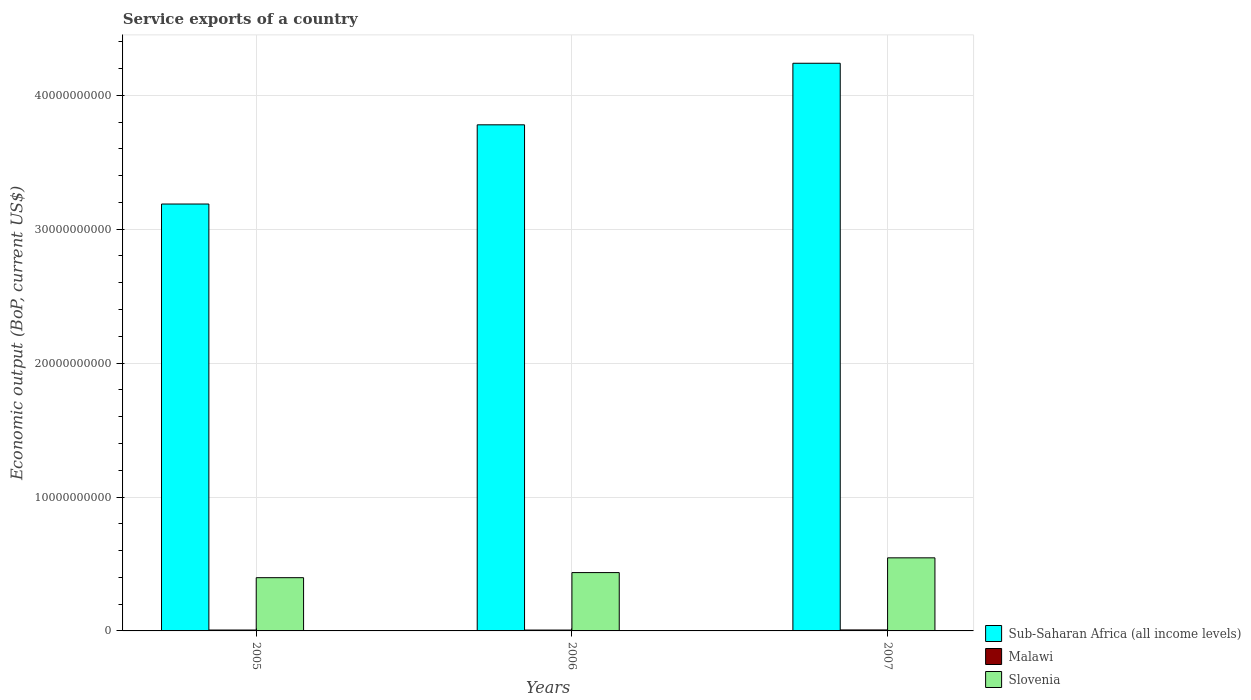Are the number of bars on each tick of the X-axis equal?
Your answer should be very brief. Yes. How many bars are there on the 2nd tick from the left?
Give a very brief answer. 3. In how many cases, is the number of bars for a given year not equal to the number of legend labels?
Offer a very short reply. 0. What is the service exports in Sub-Saharan Africa (all income levels) in 2005?
Make the answer very short. 3.19e+1. Across all years, what is the maximum service exports in Slovenia?
Provide a succinct answer. 5.46e+09. Across all years, what is the minimum service exports in Slovenia?
Your response must be concise. 3.98e+09. In which year was the service exports in Slovenia maximum?
Provide a succinct answer. 2007. In which year was the service exports in Malawi minimum?
Offer a terse response. 2006. What is the total service exports in Slovenia in the graph?
Your response must be concise. 1.38e+1. What is the difference between the service exports in Malawi in 2005 and that in 2007?
Give a very brief answer. -6.69e+06. What is the difference between the service exports in Slovenia in 2007 and the service exports in Malawi in 2006?
Offer a very short reply. 5.39e+09. What is the average service exports in Sub-Saharan Africa (all income levels) per year?
Provide a short and direct response. 3.74e+1. In the year 2007, what is the difference between the service exports in Malawi and service exports in Slovenia?
Your answer should be compact. -5.38e+09. What is the ratio of the service exports in Sub-Saharan Africa (all income levels) in 2005 to that in 2007?
Provide a short and direct response. 0.75. Is the difference between the service exports in Malawi in 2005 and 2007 greater than the difference between the service exports in Slovenia in 2005 and 2007?
Make the answer very short. Yes. What is the difference between the highest and the second highest service exports in Slovenia?
Provide a short and direct response. 1.10e+09. What is the difference between the highest and the lowest service exports in Sub-Saharan Africa (all income levels)?
Provide a short and direct response. 1.05e+1. In how many years, is the service exports in Slovenia greater than the average service exports in Slovenia taken over all years?
Keep it short and to the point. 1. What does the 3rd bar from the left in 2006 represents?
Provide a short and direct response. Slovenia. What does the 2nd bar from the right in 2005 represents?
Offer a very short reply. Malawi. How many bars are there?
Your response must be concise. 9. How many years are there in the graph?
Offer a very short reply. 3. What is the difference between two consecutive major ticks on the Y-axis?
Keep it short and to the point. 1.00e+1. Where does the legend appear in the graph?
Ensure brevity in your answer.  Bottom right. What is the title of the graph?
Your answer should be very brief. Service exports of a country. Does "Aruba" appear as one of the legend labels in the graph?
Your response must be concise. No. What is the label or title of the Y-axis?
Offer a very short reply. Economic output (BoP, current US$). What is the Economic output (BoP, current US$) of Sub-Saharan Africa (all income levels) in 2005?
Your response must be concise. 3.19e+1. What is the Economic output (BoP, current US$) in Malawi in 2005?
Offer a terse response. 6.73e+07. What is the Economic output (BoP, current US$) of Slovenia in 2005?
Give a very brief answer. 3.98e+09. What is the Economic output (BoP, current US$) of Sub-Saharan Africa (all income levels) in 2006?
Make the answer very short. 3.78e+1. What is the Economic output (BoP, current US$) in Malawi in 2006?
Ensure brevity in your answer.  6.45e+07. What is the Economic output (BoP, current US$) in Slovenia in 2006?
Give a very brief answer. 4.36e+09. What is the Economic output (BoP, current US$) of Sub-Saharan Africa (all income levels) in 2007?
Your answer should be very brief. 4.24e+1. What is the Economic output (BoP, current US$) of Malawi in 2007?
Provide a short and direct response. 7.40e+07. What is the Economic output (BoP, current US$) of Slovenia in 2007?
Your answer should be very brief. 5.46e+09. Across all years, what is the maximum Economic output (BoP, current US$) in Sub-Saharan Africa (all income levels)?
Offer a very short reply. 4.24e+1. Across all years, what is the maximum Economic output (BoP, current US$) of Malawi?
Your answer should be very brief. 7.40e+07. Across all years, what is the maximum Economic output (BoP, current US$) in Slovenia?
Make the answer very short. 5.46e+09. Across all years, what is the minimum Economic output (BoP, current US$) of Sub-Saharan Africa (all income levels)?
Your response must be concise. 3.19e+1. Across all years, what is the minimum Economic output (BoP, current US$) in Malawi?
Offer a terse response. 6.45e+07. Across all years, what is the minimum Economic output (BoP, current US$) of Slovenia?
Your answer should be compact. 3.98e+09. What is the total Economic output (BoP, current US$) of Sub-Saharan Africa (all income levels) in the graph?
Your answer should be compact. 1.12e+11. What is the total Economic output (BoP, current US$) of Malawi in the graph?
Keep it short and to the point. 2.06e+08. What is the total Economic output (BoP, current US$) of Slovenia in the graph?
Give a very brief answer. 1.38e+1. What is the difference between the Economic output (BoP, current US$) in Sub-Saharan Africa (all income levels) in 2005 and that in 2006?
Offer a terse response. -5.91e+09. What is the difference between the Economic output (BoP, current US$) of Malawi in 2005 and that in 2006?
Provide a short and direct response. 2.81e+06. What is the difference between the Economic output (BoP, current US$) in Slovenia in 2005 and that in 2006?
Your answer should be compact. -3.81e+08. What is the difference between the Economic output (BoP, current US$) of Sub-Saharan Africa (all income levels) in 2005 and that in 2007?
Provide a short and direct response. -1.05e+1. What is the difference between the Economic output (BoP, current US$) of Malawi in 2005 and that in 2007?
Provide a short and direct response. -6.69e+06. What is the difference between the Economic output (BoP, current US$) in Slovenia in 2005 and that in 2007?
Offer a very short reply. -1.48e+09. What is the difference between the Economic output (BoP, current US$) of Sub-Saharan Africa (all income levels) in 2006 and that in 2007?
Offer a very short reply. -4.60e+09. What is the difference between the Economic output (BoP, current US$) of Malawi in 2006 and that in 2007?
Make the answer very short. -9.50e+06. What is the difference between the Economic output (BoP, current US$) of Slovenia in 2006 and that in 2007?
Your response must be concise. -1.10e+09. What is the difference between the Economic output (BoP, current US$) of Sub-Saharan Africa (all income levels) in 2005 and the Economic output (BoP, current US$) of Malawi in 2006?
Your response must be concise. 3.18e+1. What is the difference between the Economic output (BoP, current US$) of Sub-Saharan Africa (all income levels) in 2005 and the Economic output (BoP, current US$) of Slovenia in 2006?
Offer a terse response. 2.75e+1. What is the difference between the Economic output (BoP, current US$) in Malawi in 2005 and the Economic output (BoP, current US$) in Slovenia in 2006?
Your answer should be compact. -4.29e+09. What is the difference between the Economic output (BoP, current US$) of Sub-Saharan Africa (all income levels) in 2005 and the Economic output (BoP, current US$) of Malawi in 2007?
Keep it short and to the point. 3.18e+1. What is the difference between the Economic output (BoP, current US$) in Sub-Saharan Africa (all income levels) in 2005 and the Economic output (BoP, current US$) in Slovenia in 2007?
Offer a terse response. 2.64e+1. What is the difference between the Economic output (BoP, current US$) of Malawi in 2005 and the Economic output (BoP, current US$) of Slovenia in 2007?
Your answer should be very brief. -5.39e+09. What is the difference between the Economic output (BoP, current US$) of Sub-Saharan Africa (all income levels) in 2006 and the Economic output (BoP, current US$) of Malawi in 2007?
Give a very brief answer. 3.77e+1. What is the difference between the Economic output (BoP, current US$) of Sub-Saharan Africa (all income levels) in 2006 and the Economic output (BoP, current US$) of Slovenia in 2007?
Your answer should be compact. 3.23e+1. What is the difference between the Economic output (BoP, current US$) in Malawi in 2006 and the Economic output (BoP, current US$) in Slovenia in 2007?
Ensure brevity in your answer.  -5.39e+09. What is the average Economic output (BoP, current US$) of Sub-Saharan Africa (all income levels) per year?
Your answer should be compact. 3.74e+1. What is the average Economic output (BoP, current US$) of Malawi per year?
Your answer should be very brief. 6.86e+07. What is the average Economic output (BoP, current US$) in Slovenia per year?
Ensure brevity in your answer.  4.60e+09. In the year 2005, what is the difference between the Economic output (BoP, current US$) in Sub-Saharan Africa (all income levels) and Economic output (BoP, current US$) in Malawi?
Keep it short and to the point. 3.18e+1. In the year 2005, what is the difference between the Economic output (BoP, current US$) of Sub-Saharan Africa (all income levels) and Economic output (BoP, current US$) of Slovenia?
Your answer should be very brief. 2.79e+1. In the year 2005, what is the difference between the Economic output (BoP, current US$) in Malawi and Economic output (BoP, current US$) in Slovenia?
Your response must be concise. -3.91e+09. In the year 2006, what is the difference between the Economic output (BoP, current US$) of Sub-Saharan Africa (all income levels) and Economic output (BoP, current US$) of Malawi?
Your response must be concise. 3.77e+1. In the year 2006, what is the difference between the Economic output (BoP, current US$) of Sub-Saharan Africa (all income levels) and Economic output (BoP, current US$) of Slovenia?
Your answer should be compact. 3.34e+1. In the year 2006, what is the difference between the Economic output (BoP, current US$) of Malawi and Economic output (BoP, current US$) of Slovenia?
Provide a succinct answer. -4.29e+09. In the year 2007, what is the difference between the Economic output (BoP, current US$) of Sub-Saharan Africa (all income levels) and Economic output (BoP, current US$) of Malawi?
Your answer should be compact. 4.23e+1. In the year 2007, what is the difference between the Economic output (BoP, current US$) in Sub-Saharan Africa (all income levels) and Economic output (BoP, current US$) in Slovenia?
Your response must be concise. 3.69e+1. In the year 2007, what is the difference between the Economic output (BoP, current US$) in Malawi and Economic output (BoP, current US$) in Slovenia?
Provide a short and direct response. -5.38e+09. What is the ratio of the Economic output (BoP, current US$) of Sub-Saharan Africa (all income levels) in 2005 to that in 2006?
Offer a terse response. 0.84. What is the ratio of the Economic output (BoP, current US$) of Malawi in 2005 to that in 2006?
Your answer should be compact. 1.04. What is the ratio of the Economic output (BoP, current US$) in Slovenia in 2005 to that in 2006?
Your answer should be compact. 0.91. What is the ratio of the Economic output (BoP, current US$) of Sub-Saharan Africa (all income levels) in 2005 to that in 2007?
Provide a short and direct response. 0.75. What is the ratio of the Economic output (BoP, current US$) in Malawi in 2005 to that in 2007?
Your answer should be compact. 0.91. What is the ratio of the Economic output (BoP, current US$) of Slovenia in 2005 to that in 2007?
Your answer should be compact. 0.73. What is the ratio of the Economic output (BoP, current US$) of Sub-Saharan Africa (all income levels) in 2006 to that in 2007?
Provide a succinct answer. 0.89. What is the ratio of the Economic output (BoP, current US$) in Malawi in 2006 to that in 2007?
Make the answer very short. 0.87. What is the ratio of the Economic output (BoP, current US$) in Slovenia in 2006 to that in 2007?
Offer a terse response. 0.8. What is the difference between the highest and the second highest Economic output (BoP, current US$) of Sub-Saharan Africa (all income levels)?
Your response must be concise. 4.60e+09. What is the difference between the highest and the second highest Economic output (BoP, current US$) of Malawi?
Provide a succinct answer. 6.69e+06. What is the difference between the highest and the second highest Economic output (BoP, current US$) of Slovenia?
Provide a short and direct response. 1.10e+09. What is the difference between the highest and the lowest Economic output (BoP, current US$) in Sub-Saharan Africa (all income levels)?
Make the answer very short. 1.05e+1. What is the difference between the highest and the lowest Economic output (BoP, current US$) in Malawi?
Your answer should be very brief. 9.50e+06. What is the difference between the highest and the lowest Economic output (BoP, current US$) of Slovenia?
Your answer should be compact. 1.48e+09. 